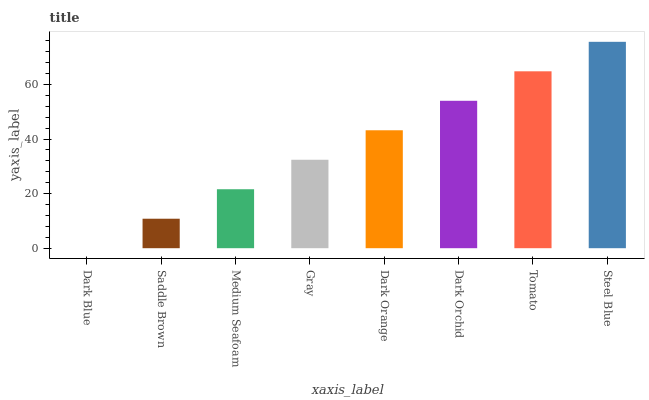Is Dark Blue the minimum?
Answer yes or no. Yes. Is Steel Blue the maximum?
Answer yes or no. Yes. Is Saddle Brown the minimum?
Answer yes or no. No. Is Saddle Brown the maximum?
Answer yes or no. No. Is Saddle Brown greater than Dark Blue?
Answer yes or no. Yes. Is Dark Blue less than Saddle Brown?
Answer yes or no. Yes. Is Dark Blue greater than Saddle Brown?
Answer yes or no. No. Is Saddle Brown less than Dark Blue?
Answer yes or no. No. Is Dark Orange the high median?
Answer yes or no. Yes. Is Gray the low median?
Answer yes or no. Yes. Is Steel Blue the high median?
Answer yes or no. No. Is Dark Blue the low median?
Answer yes or no. No. 